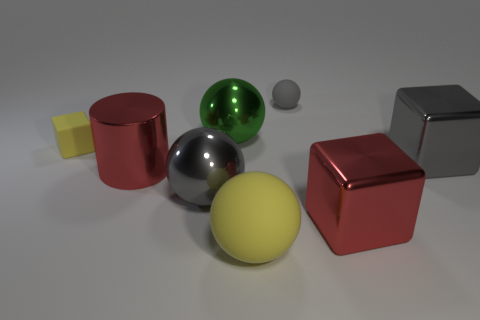Is the color of the large matte object the same as the tiny rubber cube?
Ensure brevity in your answer.  Yes. There is a yellow rubber thing behind the large yellow sphere; what number of large red objects are in front of it?
Your answer should be very brief. 2. How many big cylinders are the same material as the gray cube?
Your response must be concise. 1. How many small objects are either rubber cubes or balls?
Offer a very short reply. 2. The large thing that is on the right side of the big green object and left of the small gray thing has what shape?
Give a very brief answer. Sphere. Is the material of the small sphere the same as the large yellow thing?
Your response must be concise. Yes. What color is the rubber sphere that is the same size as the metallic cylinder?
Provide a short and direct response. Yellow. What is the color of the matte object that is both behind the large matte thing and to the right of the large red cylinder?
Provide a succinct answer. Gray. There is a metal thing that is the same color as the large shiny cylinder; what size is it?
Ensure brevity in your answer.  Large. There is a thing that is the same color as the large cylinder; what shape is it?
Give a very brief answer. Cube. 